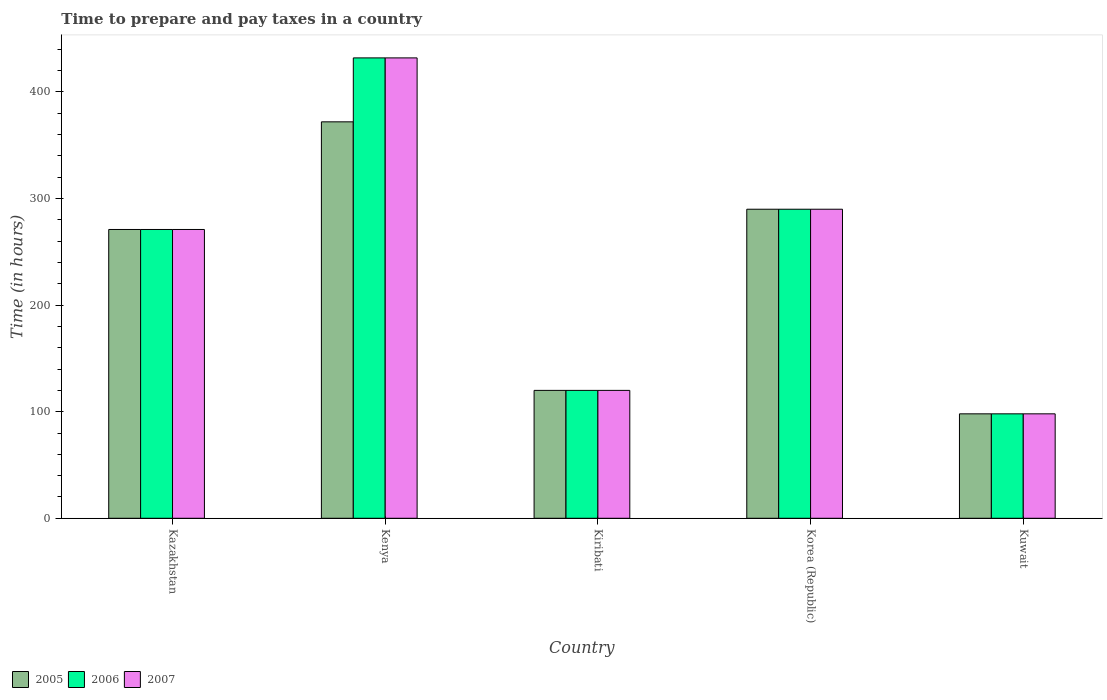How many different coloured bars are there?
Give a very brief answer. 3. Are the number of bars per tick equal to the number of legend labels?
Your response must be concise. Yes. Are the number of bars on each tick of the X-axis equal?
Give a very brief answer. Yes. How many bars are there on the 4th tick from the left?
Offer a terse response. 3. What is the label of the 3rd group of bars from the left?
Give a very brief answer. Kiribati. What is the number of hours required to prepare and pay taxes in 2006 in Korea (Republic)?
Give a very brief answer. 290. Across all countries, what is the maximum number of hours required to prepare and pay taxes in 2006?
Your answer should be compact. 432. In which country was the number of hours required to prepare and pay taxes in 2006 maximum?
Your response must be concise. Kenya. In which country was the number of hours required to prepare and pay taxes in 2005 minimum?
Provide a succinct answer. Kuwait. What is the total number of hours required to prepare and pay taxes in 2007 in the graph?
Make the answer very short. 1211. What is the difference between the number of hours required to prepare and pay taxes in 2005 in Kuwait and the number of hours required to prepare and pay taxes in 2006 in Korea (Republic)?
Provide a short and direct response. -192. What is the average number of hours required to prepare and pay taxes in 2007 per country?
Provide a short and direct response. 242.2. In how many countries, is the number of hours required to prepare and pay taxes in 2006 greater than 40 hours?
Ensure brevity in your answer.  5. What is the ratio of the number of hours required to prepare and pay taxes in 2006 in Kenya to that in Korea (Republic)?
Offer a terse response. 1.49. Is the number of hours required to prepare and pay taxes in 2007 in Kazakhstan less than that in Kenya?
Keep it short and to the point. Yes. Is the difference between the number of hours required to prepare and pay taxes in 2007 in Kiribati and Kuwait greater than the difference between the number of hours required to prepare and pay taxes in 2006 in Kiribati and Kuwait?
Offer a terse response. No. What is the difference between the highest and the second highest number of hours required to prepare and pay taxes in 2006?
Your response must be concise. 142. What is the difference between the highest and the lowest number of hours required to prepare and pay taxes in 2006?
Make the answer very short. 334. In how many countries, is the number of hours required to prepare and pay taxes in 2007 greater than the average number of hours required to prepare and pay taxes in 2007 taken over all countries?
Provide a short and direct response. 3. Is the sum of the number of hours required to prepare and pay taxes in 2005 in Kenya and Kiribati greater than the maximum number of hours required to prepare and pay taxes in 2006 across all countries?
Offer a terse response. Yes. How many bars are there?
Provide a succinct answer. 15. What is the difference between two consecutive major ticks on the Y-axis?
Keep it short and to the point. 100. Are the values on the major ticks of Y-axis written in scientific E-notation?
Ensure brevity in your answer.  No. Does the graph contain grids?
Offer a terse response. No. Where does the legend appear in the graph?
Offer a terse response. Bottom left. What is the title of the graph?
Your response must be concise. Time to prepare and pay taxes in a country. What is the label or title of the Y-axis?
Offer a very short reply. Time (in hours). What is the Time (in hours) of 2005 in Kazakhstan?
Make the answer very short. 271. What is the Time (in hours) of 2006 in Kazakhstan?
Your answer should be compact. 271. What is the Time (in hours) of 2007 in Kazakhstan?
Offer a terse response. 271. What is the Time (in hours) in 2005 in Kenya?
Offer a terse response. 372. What is the Time (in hours) of 2006 in Kenya?
Make the answer very short. 432. What is the Time (in hours) in 2007 in Kenya?
Your answer should be very brief. 432. What is the Time (in hours) of 2005 in Kiribati?
Provide a short and direct response. 120. What is the Time (in hours) of 2006 in Kiribati?
Keep it short and to the point. 120. What is the Time (in hours) in 2007 in Kiribati?
Your response must be concise. 120. What is the Time (in hours) in 2005 in Korea (Republic)?
Provide a succinct answer. 290. What is the Time (in hours) of 2006 in Korea (Republic)?
Give a very brief answer. 290. What is the Time (in hours) of 2007 in Korea (Republic)?
Your answer should be very brief. 290. What is the Time (in hours) in 2007 in Kuwait?
Keep it short and to the point. 98. Across all countries, what is the maximum Time (in hours) of 2005?
Provide a short and direct response. 372. Across all countries, what is the maximum Time (in hours) in 2006?
Keep it short and to the point. 432. Across all countries, what is the maximum Time (in hours) in 2007?
Offer a terse response. 432. Across all countries, what is the minimum Time (in hours) of 2005?
Offer a very short reply. 98. What is the total Time (in hours) in 2005 in the graph?
Make the answer very short. 1151. What is the total Time (in hours) in 2006 in the graph?
Your answer should be compact. 1211. What is the total Time (in hours) in 2007 in the graph?
Your answer should be compact. 1211. What is the difference between the Time (in hours) of 2005 in Kazakhstan and that in Kenya?
Provide a succinct answer. -101. What is the difference between the Time (in hours) in 2006 in Kazakhstan and that in Kenya?
Offer a very short reply. -161. What is the difference between the Time (in hours) of 2007 in Kazakhstan and that in Kenya?
Offer a terse response. -161. What is the difference between the Time (in hours) of 2005 in Kazakhstan and that in Kiribati?
Offer a very short reply. 151. What is the difference between the Time (in hours) of 2006 in Kazakhstan and that in Kiribati?
Ensure brevity in your answer.  151. What is the difference between the Time (in hours) of 2007 in Kazakhstan and that in Kiribati?
Provide a short and direct response. 151. What is the difference between the Time (in hours) in 2005 in Kazakhstan and that in Korea (Republic)?
Provide a short and direct response. -19. What is the difference between the Time (in hours) in 2006 in Kazakhstan and that in Korea (Republic)?
Provide a short and direct response. -19. What is the difference between the Time (in hours) in 2007 in Kazakhstan and that in Korea (Republic)?
Your answer should be very brief. -19. What is the difference between the Time (in hours) of 2005 in Kazakhstan and that in Kuwait?
Your answer should be very brief. 173. What is the difference between the Time (in hours) in 2006 in Kazakhstan and that in Kuwait?
Ensure brevity in your answer.  173. What is the difference between the Time (in hours) in 2007 in Kazakhstan and that in Kuwait?
Offer a very short reply. 173. What is the difference between the Time (in hours) of 2005 in Kenya and that in Kiribati?
Make the answer very short. 252. What is the difference between the Time (in hours) in 2006 in Kenya and that in Kiribati?
Give a very brief answer. 312. What is the difference between the Time (in hours) in 2007 in Kenya and that in Kiribati?
Your answer should be very brief. 312. What is the difference between the Time (in hours) in 2005 in Kenya and that in Korea (Republic)?
Your answer should be very brief. 82. What is the difference between the Time (in hours) of 2006 in Kenya and that in Korea (Republic)?
Provide a succinct answer. 142. What is the difference between the Time (in hours) in 2007 in Kenya and that in Korea (Republic)?
Keep it short and to the point. 142. What is the difference between the Time (in hours) in 2005 in Kenya and that in Kuwait?
Offer a very short reply. 274. What is the difference between the Time (in hours) in 2006 in Kenya and that in Kuwait?
Offer a terse response. 334. What is the difference between the Time (in hours) of 2007 in Kenya and that in Kuwait?
Make the answer very short. 334. What is the difference between the Time (in hours) of 2005 in Kiribati and that in Korea (Republic)?
Your answer should be very brief. -170. What is the difference between the Time (in hours) of 2006 in Kiribati and that in Korea (Republic)?
Offer a terse response. -170. What is the difference between the Time (in hours) in 2007 in Kiribati and that in Korea (Republic)?
Your response must be concise. -170. What is the difference between the Time (in hours) in 2005 in Kiribati and that in Kuwait?
Give a very brief answer. 22. What is the difference between the Time (in hours) in 2006 in Kiribati and that in Kuwait?
Your response must be concise. 22. What is the difference between the Time (in hours) in 2007 in Kiribati and that in Kuwait?
Offer a very short reply. 22. What is the difference between the Time (in hours) of 2005 in Korea (Republic) and that in Kuwait?
Offer a very short reply. 192. What is the difference between the Time (in hours) in 2006 in Korea (Republic) and that in Kuwait?
Your answer should be very brief. 192. What is the difference between the Time (in hours) of 2007 in Korea (Republic) and that in Kuwait?
Provide a short and direct response. 192. What is the difference between the Time (in hours) in 2005 in Kazakhstan and the Time (in hours) in 2006 in Kenya?
Make the answer very short. -161. What is the difference between the Time (in hours) of 2005 in Kazakhstan and the Time (in hours) of 2007 in Kenya?
Give a very brief answer. -161. What is the difference between the Time (in hours) of 2006 in Kazakhstan and the Time (in hours) of 2007 in Kenya?
Offer a terse response. -161. What is the difference between the Time (in hours) in 2005 in Kazakhstan and the Time (in hours) in 2006 in Kiribati?
Make the answer very short. 151. What is the difference between the Time (in hours) in 2005 in Kazakhstan and the Time (in hours) in 2007 in Kiribati?
Your response must be concise. 151. What is the difference between the Time (in hours) of 2006 in Kazakhstan and the Time (in hours) of 2007 in Kiribati?
Keep it short and to the point. 151. What is the difference between the Time (in hours) in 2005 in Kazakhstan and the Time (in hours) in 2007 in Korea (Republic)?
Give a very brief answer. -19. What is the difference between the Time (in hours) in 2005 in Kazakhstan and the Time (in hours) in 2006 in Kuwait?
Your answer should be compact. 173. What is the difference between the Time (in hours) in 2005 in Kazakhstan and the Time (in hours) in 2007 in Kuwait?
Ensure brevity in your answer.  173. What is the difference between the Time (in hours) of 2006 in Kazakhstan and the Time (in hours) of 2007 in Kuwait?
Keep it short and to the point. 173. What is the difference between the Time (in hours) of 2005 in Kenya and the Time (in hours) of 2006 in Kiribati?
Keep it short and to the point. 252. What is the difference between the Time (in hours) in 2005 in Kenya and the Time (in hours) in 2007 in Kiribati?
Keep it short and to the point. 252. What is the difference between the Time (in hours) of 2006 in Kenya and the Time (in hours) of 2007 in Kiribati?
Make the answer very short. 312. What is the difference between the Time (in hours) of 2005 in Kenya and the Time (in hours) of 2007 in Korea (Republic)?
Ensure brevity in your answer.  82. What is the difference between the Time (in hours) of 2006 in Kenya and the Time (in hours) of 2007 in Korea (Republic)?
Offer a terse response. 142. What is the difference between the Time (in hours) in 2005 in Kenya and the Time (in hours) in 2006 in Kuwait?
Your answer should be very brief. 274. What is the difference between the Time (in hours) of 2005 in Kenya and the Time (in hours) of 2007 in Kuwait?
Your answer should be very brief. 274. What is the difference between the Time (in hours) of 2006 in Kenya and the Time (in hours) of 2007 in Kuwait?
Provide a short and direct response. 334. What is the difference between the Time (in hours) in 2005 in Kiribati and the Time (in hours) in 2006 in Korea (Republic)?
Make the answer very short. -170. What is the difference between the Time (in hours) of 2005 in Kiribati and the Time (in hours) of 2007 in Korea (Republic)?
Your answer should be very brief. -170. What is the difference between the Time (in hours) in 2006 in Kiribati and the Time (in hours) in 2007 in Korea (Republic)?
Your answer should be very brief. -170. What is the difference between the Time (in hours) in 2005 in Kiribati and the Time (in hours) in 2006 in Kuwait?
Your answer should be very brief. 22. What is the difference between the Time (in hours) in 2005 in Korea (Republic) and the Time (in hours) in 2006 in Kuwait?
Ensure brevity in your answer.  192. What is the difference between the Time (in hours) of 2005 in Korea (Republic) and the Time (in hours) of 2007 in Kuwait?
Give a very brief answer. 192. What is the difference between the Time (in hours) of 2006 in Korea (Republic) and the Time (in hours) of 2007 in Kuwait?
Give a very brief answer. 192. What is the average Time (in hours) of 2005 per country?
Your response must be concise. 230.2. What is the average Time (in hours) of 2006 per country?
Ensure brevity in your answer.  242.2. What is the average Time (in hours) of 2007 per country?
Keep it short and to the point. 242.2. What is the difference between the Time (in hours) of 2005 and Time (in hours) of 2007 in Kazakhstan?
Keep it short and to the point. 0. What is the difference between the Time (in hours) of 2006 and Time (in hours) of 2007 in Kazakhstan?
Offer a terse response. 0. What is the difference between the Time (in hours) in 2005 and Time (in hours) in 2006 in Kenya?
Make the answer very short. -60. What is the difference between the Time (in hours) of 2005 and Time (in hours) of 2007 in Kenya?
Your answer should be very brief. -60. What is the difference between the Time (in hours) in 2005 and Time (in hours) in 2007 in Kiribati?
Your answer should be compact. 0. What is the difference between the Time (in hours) of 2006 and Time (in hours) of 2007 in Korea (Republic)?
Offer a very short reply. 0. What is the difference between the Time (in hours) of 2005 and Time (in hours) of 2006 in Kuwait?
Your answer should be compact. 0. What is the difference between the Time (in hours) in 2006 and Time (in hours) in 2007 in Kuwait?
Your response must be concise. 0. What is the ratio of the Time (in hours) in 2005 in Kazakhstan to that in Kenya?
Make the answer very short. 0.73. What is the ratio of the Time (in hours) in 2006 in Kazakhstan to that in Kenya?
Offer a terse response. 0.63. What is the ratio of the Time (in hours) in 2007 in Kazakhstan to that in Kenya?
Your answer should be very brief. 0.63. What is the ratio of the Time (in hours) in 2005 in Kazakhstan to that in Kiribati?
Your answer should be very brief. 2.26. What is the ratio of the Time (in hours) of 2006 in Kazakhstan to that in Kiribati?
Your response must be concise. 2.26. What is the ratio of the Time (in hours) of 2007 in Kazakhstan to that in Kiribati?
Your answer should be compact. 2.26. What is the ratio of the Time (in hours) of 2005 in Kazakhstan to that in Korea (Republic)?
Give a very brief answer. 0.93. What is the ratio of the Time (in hours) of 2006 in Kazakhstan to that in Korea (Republic)?
Offer a terse response. 0.93. What is the ratio of the Time (in hours) in 2007 in Kazakhstan to that in Korea (Republic)?
Give a very brief answer. 0.93. What is the ratio of the Time (in hours) in 2005 in Kazakhstan to that in Kuwait?
Your response must be concise. 2.77. What is the ratio of the Time (in hours) of 2006 in Kazakhstan to that in Kuwait?
Give a very brief answer. 2.77. What is the ratio of the Time (in hours) of 2007 in Kazakhstan to that in Kuwait?
Offer a very short reply. 2.77. What is the ratio of the Time (in hours) in 2005 in Kenya to that in Kiribati?
Make the answer very short. 3.1. What is the ratio of the Time (in hours) of 2007 in Kenya to that in Kiribati?
Your answer should be very brief. 3.6. What is the ratio of the Time (in hours) in 2005 in Kenya to that in Korea (Republic)?
Provide a succinct answer. 1.28. What is the ratio of the Time (in hours) in 2006 in Kenya to that in Korea (Republic)?
Keep it short and to the point. 1.49. What is the ratio of the Time (in hours) of 2007 in Kenya to that in Korea (Republic)?
Your answer should be very brief. 1.49. What is the ratio of the Time (in hours) of 2005 in Kenya to that in Kuwait?
Ensure brevity in your answer.  3.8. What is the ratio of the Time (in hours) of 2006 in Kenya to that in Kuwait?
Your response must be concise. 4.41. What is the ratio of the Time (in hours) in 2007 in Kenya to that in Kuwait?
Give a very brief answer. 4.41. What is the ratio of the Time (in hours) of 2005 in Kiribati to that in Korea (Republic)?
Provide a succinct answer. 0.41. What is the ratio of the Time (in hours) in 2006 in Kiribati to that in Korea (Republic)?
Provide a succinct answer. 0.41. What is the ratio of the Time (in hours) in 2007 in Kiribati to that in Korea (Republic)?
Your answer should be compact. 0.41. What is the ratio of the Time (in hours) of 2005 in Kiribati to that in Kuwait?
Provide a short and direct response. 1.22. What is the ratio of the Time (in hours) of 2006 in Kiribati to that in Kuwait?
Make the answer very short. 1.22. What is the ratio of the Time (in hours) of 2007 in Kiribati to that in Kuwait?
Provide a succinct answer. 1.22. What is the ratio of the Time (in hours) of 2005 in Korea (Republic) to that in Kuwait?
Your response must be concise. 2.96. What is the ratio of the Time (in hours) of 2006 in Korea (Republic) to that in Kuwait?
Keep it short and to the point. 2.96. What is the ratio of the Time (in hours) of 2007 in Korea (Republic) to that in Kuwait?
Your answer should be very brief. 2.96. What is the difference between the highest and the second highest Time (in hours) of 2006?
Make the answer very short. 142. What is the difference between the highest and the second highest Time (in hours) in 2007?
Give a very brief answer. 142. What is the difference between the highest and the lowest Time (in hours) of 2005?
Ensure brevity in your answer.  274. What is the difference between the highest and the lowest Time (in hours) of 2006?
Offer a terse response. 334. What is the difference between the highest and the lowest Time (in hours) in 2007?
Provide a short and direct response. 334. 